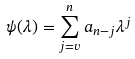Convert formula to latex. <formula><loc_0><loc_0><loc_500><loc_500>\psi ( \lambda ) = \sum _ { j = v } ^ { n } a _ { n - j } \lambda ^ { j }</formula> 